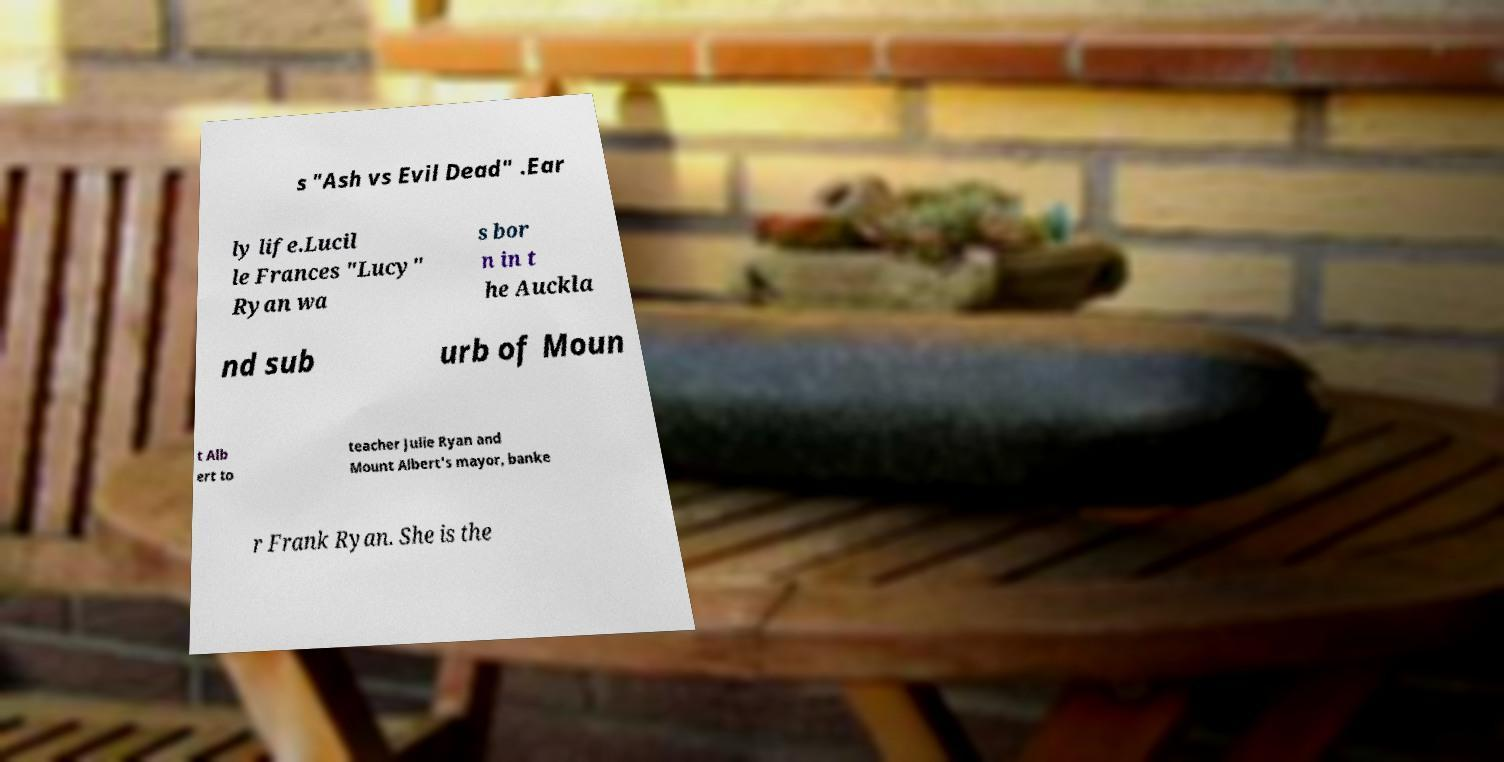Could you assist in decoding the text presented in this image and type it out clearly? s "Ash vs Evil Dead" .Ear ly life.Lucil le Frances "Lucy" Ryan wa s bor n in t he Auckla nd sub urb of Moun t Alb ert to teacher Julie Ryan and Mount Albert's mayor, banke r Frank Ryan. She is the 